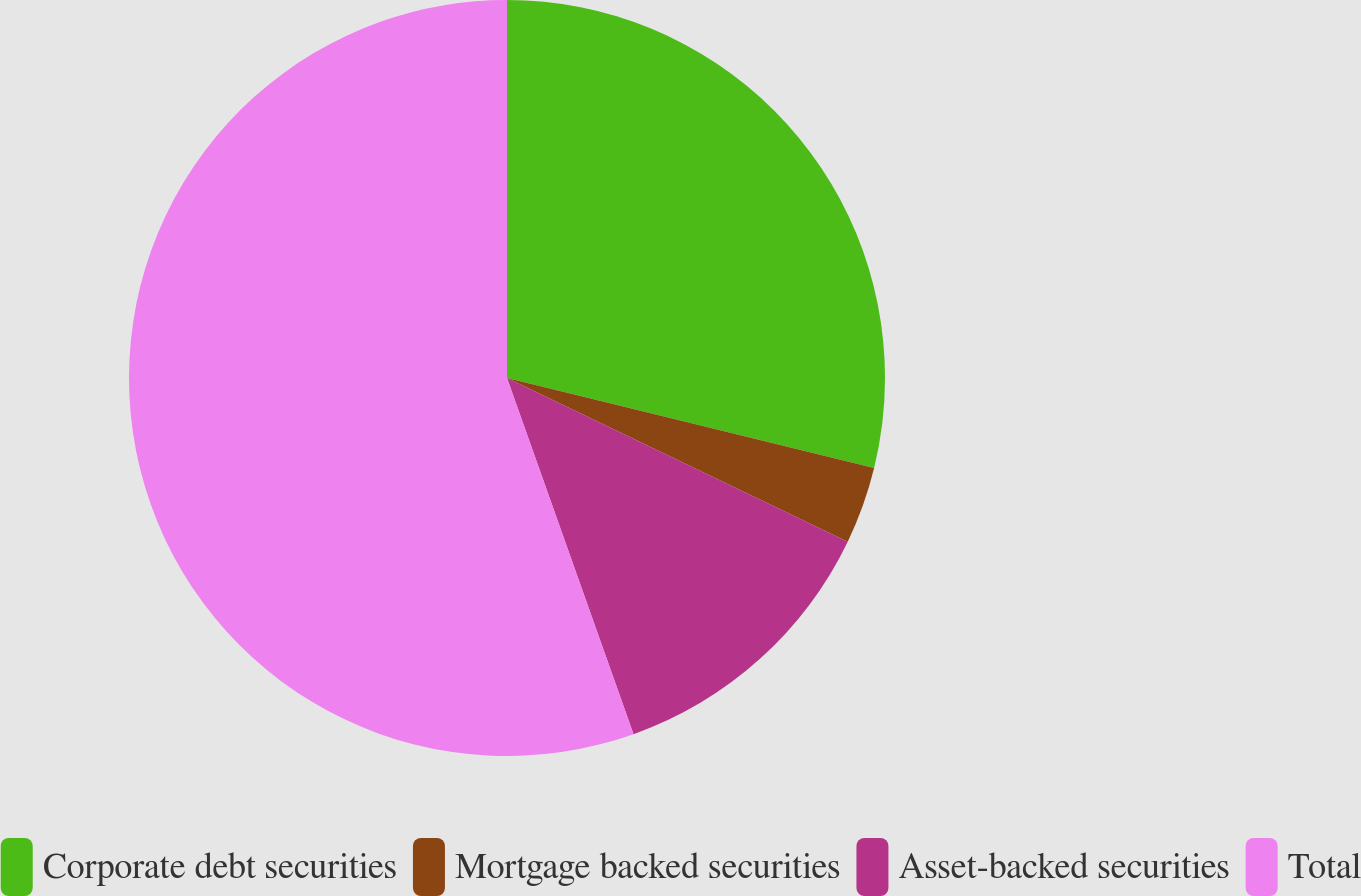Convert chart to OTSL. <chart><loc_0><loc_0><loc_500><loc_500><pie_chart><fcel>Corporate debt securities<fcel>Mortgage backed securities<fcel>Asset-backed securities<fcel>Total<nl><fcel>28.83%<fcel>3.3%<fcel>12.44%<fcel>55.44%<nl></chart> 